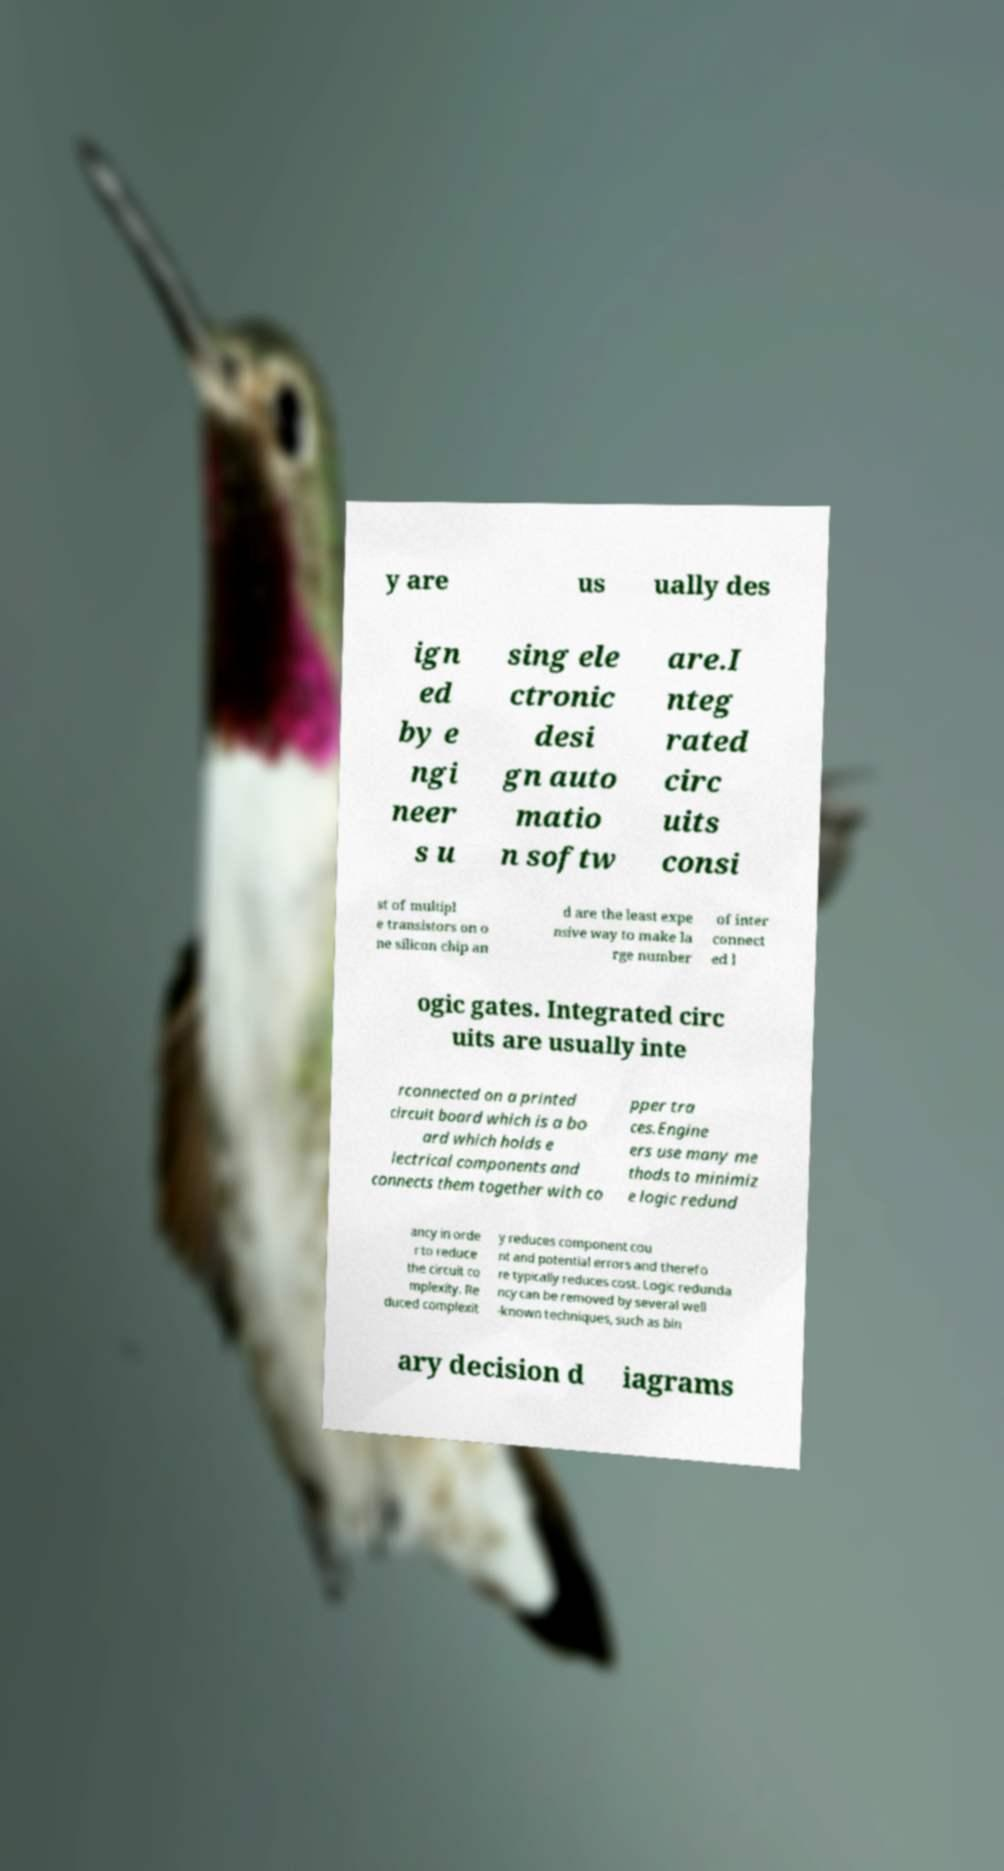Could you extract and type out the text from this image? y are us ually des ign ed by e ngi neer s u sing ele ctronic desi gn auto matio n softw are.I nteg rated circ uits consi st of multipl e transistors on o ne silicon chip an d are the least expe nsive way to make la rge number of inter connect ed l ogic gates. Integrated circ uits are usually inte rconnected on a printed circuit board which is a bo ard which holds e lectrical components and connects them together with co pper tra ces.Engine ers use many me thods to minimiz e logic redund ancy in orde r to reduce the circuit co mplexity. Re duced complexit y reduces component cou nt and potential errors and therefo re typically reduces cost. Logic redunda ncy can be removed by several well -known techniques, such as bin ary decision d iagrams 